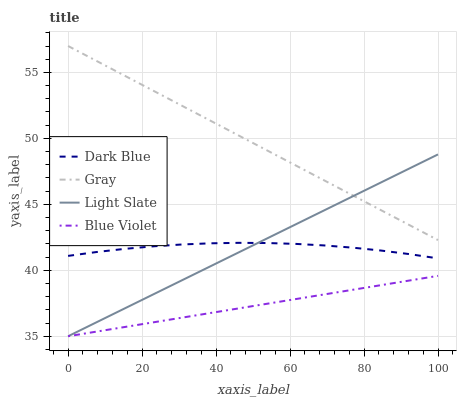Does Blue Violet have the minimum area under the curve?
Answer yes or no. Yes. Does Gray have the maximum area under the curve?
Answer yes or no. Yes. Does Dark Blue have the minimum area under the curve?
Answer yes or no. No. Does Dark Blue have the maximum area under the curve?
Answer yes or no. No. Is Light Slate the smoothest?
Answer yes or no. Yes. Is Dark Blue the roughest?
Answer yes or no. Yes. Is Blue Violet the smoothest?
Answer yes or no. No. Is Blue Violet the roughest?
Answer yes or no. No. Does Light Slate have the lowest value?
Answer yes or no. Yes. Does Dark Blue have the lowest value?
Answer yes or no. No. Does Gray have the highest value?
Answer yes or no. Yes. Does Dark Blue have the highest value?
Answer yes or no. No. Is Blue Violet less than Gray?
Answer yes or no. Yes. Is Gray greater than Dark Blue?
Answer yes or no. Yes. Does Blue Violet intersect Light Slate?
Answer yes or no. Yes. Is Blue Violet less than Light Slate?
Answer yes or no. No. Is Blue Violet greater than Light Slate?
Answer yes or no. No. Does Blue Violet intersect Gray?
Answer yes or no. No. 